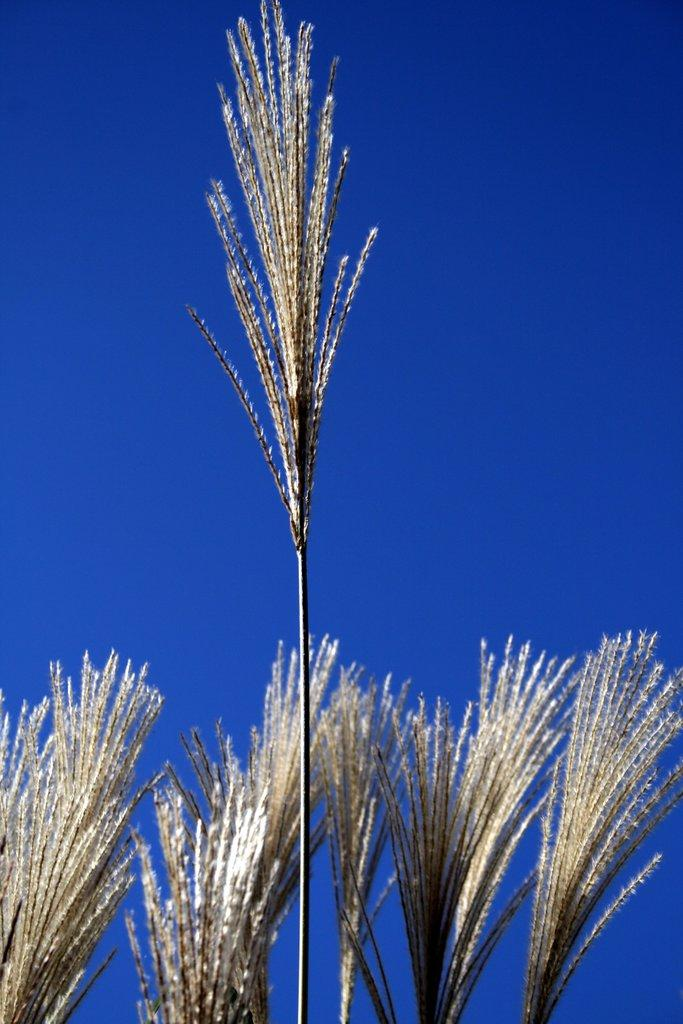What type of living organisms can be seen in the image? Plants can be seen in the image. What part of the natural environment is visible in the image? The sky is visible in the image. What type of wire is being used to hold the feast in the image? There is no feast or wire present in the image; it only features plants and the sky. What kind of rock can be seen in the image? There is no rock present in the image; it only features plants and the sky. 